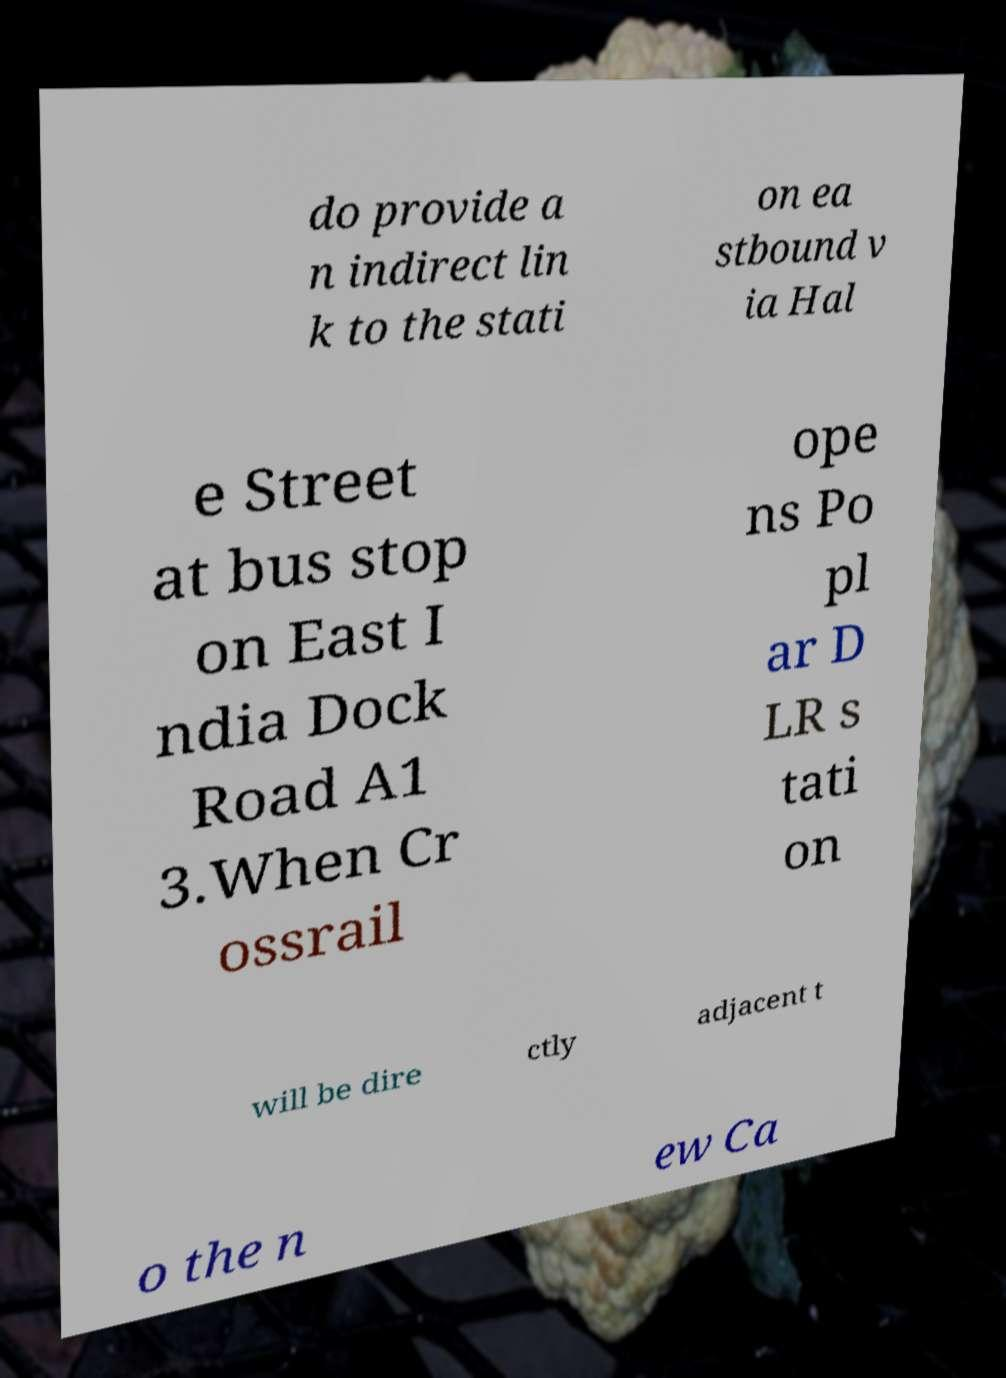Please read and relay the text visible in this image. What does it say? do provide a n indirect lin k to the stati on ea stbound v ia Hal e Street at bus stop on East I ndia Dock Road A1 3.When Cr ossrail ope ns Po pl ar D LR s tati on will be dire ctly adjacent t o the n ew Ca 